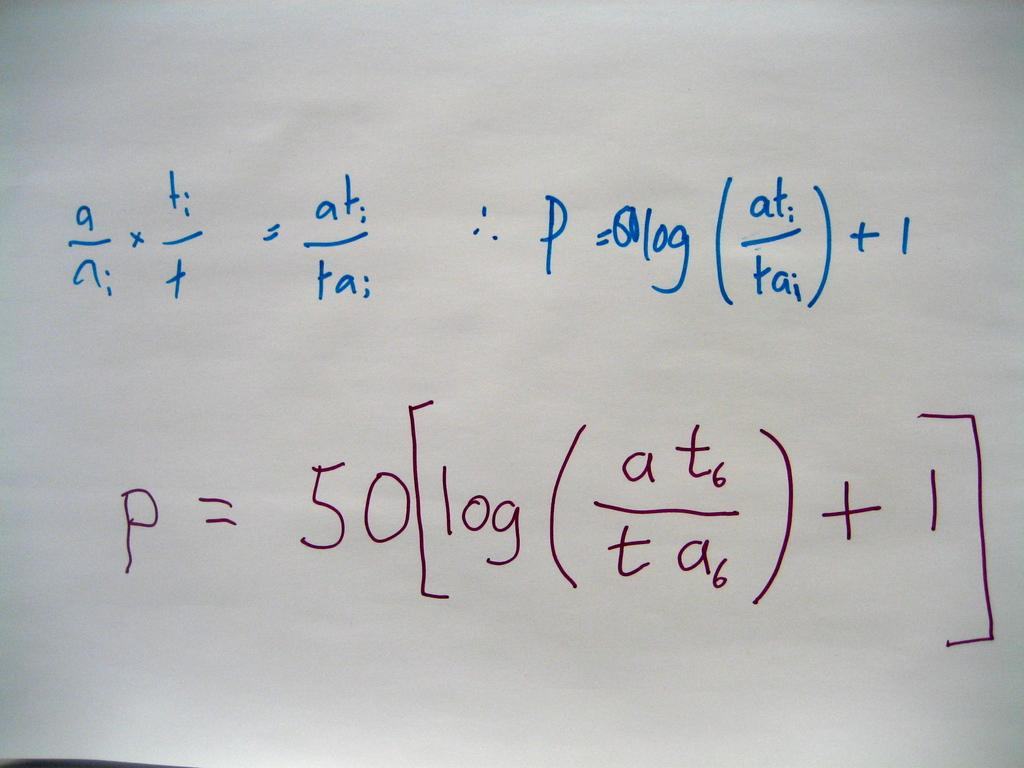Provide a one-sentence caption for the provided image. A very long math equation starting with the letter "a". 